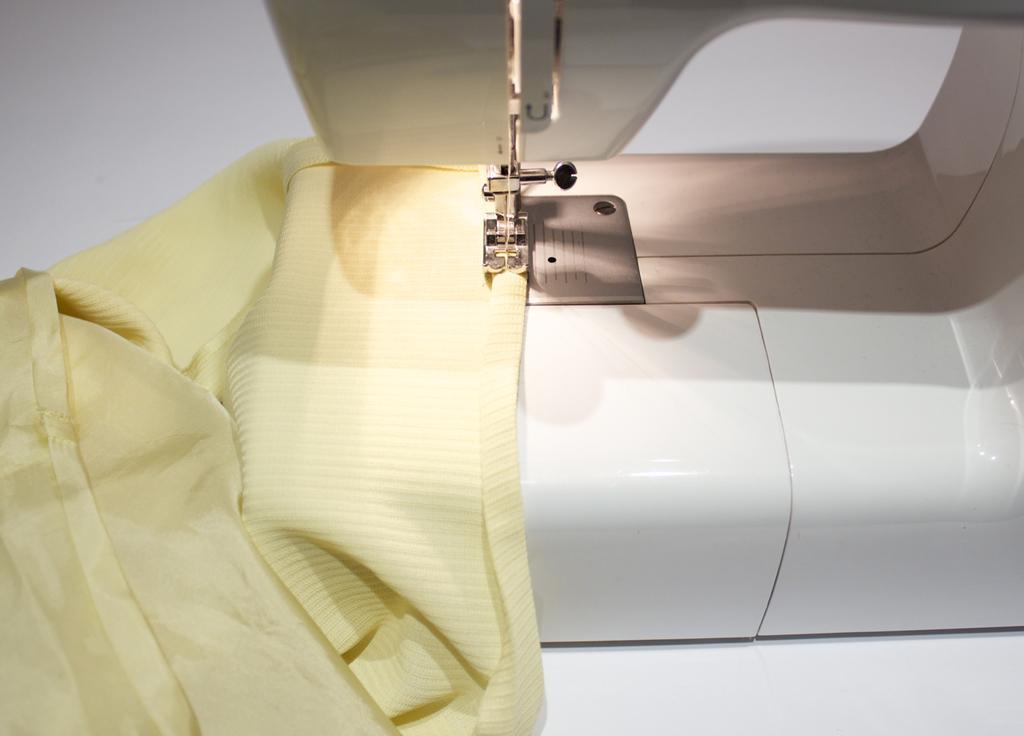Can you describe this image briefly? In this image we can see a sewing machine with a cloth placed on the surface. 